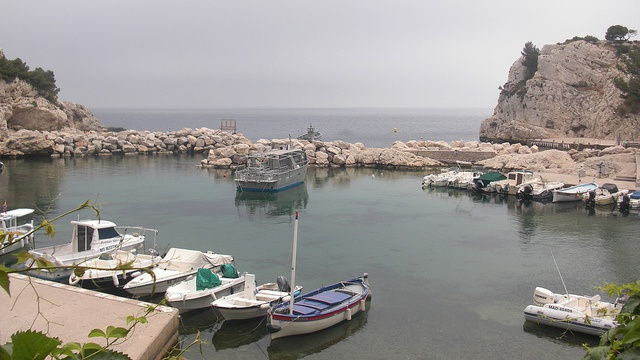Describe the objects in this image and their specific colors. I can see boat in lightgray, gray, darkgray, black, and navy tones, boat in lightgray, gray, darkgray, and black tones, boat in lightgray, darkgray, and gray tones, boat in lightgray, black, darkgray, and gray tones, and boat in lightgray, white, gray, and darkgray tones in this image. 